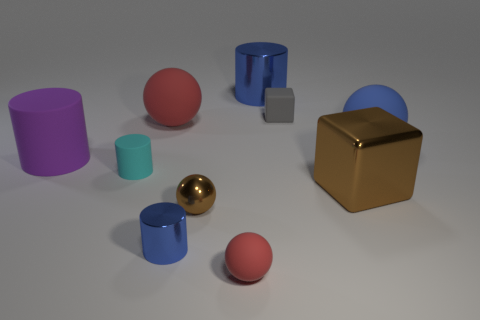There is a gray rubber thing; what shape is it?
Your answer should be compact. Cube. What is the big object that is in front of the cylinder left of the tiny cyan thing made of?
Provide a short and direct response. Metal. How many other things are there of the same material as the small red sphere?
Offer a terse response. 5. There is a red ball that is the same size as the brown sphere; what is its material?
Offer a terse response. Rubber. Is the number of tiny metallic objects to the right of the brown ball greater than the number of big matte objects in front of the purple rubber object?
Your response must be concise. No. Is there a small brown thing that has the same shape as the large red thing?
Offer a terse response. Yes. What shape is the purple object that is the same size as the blue ball?
Your answer should be very brief. Cylinder. What is the shape of the big matte object that is on the right side of the large red sphere?
Ensure brevity in your answer.  Sphere. Are there fewer blue metallic cylinders to the left of the gray block than things to the right of the small rubber ball?
Make the answer very short. Yes. Is the size of the purple matte cylinder the same as the blue metallic cylinder that is behind the tiny cyan thing?
Provide a succinct answer. Yes. 